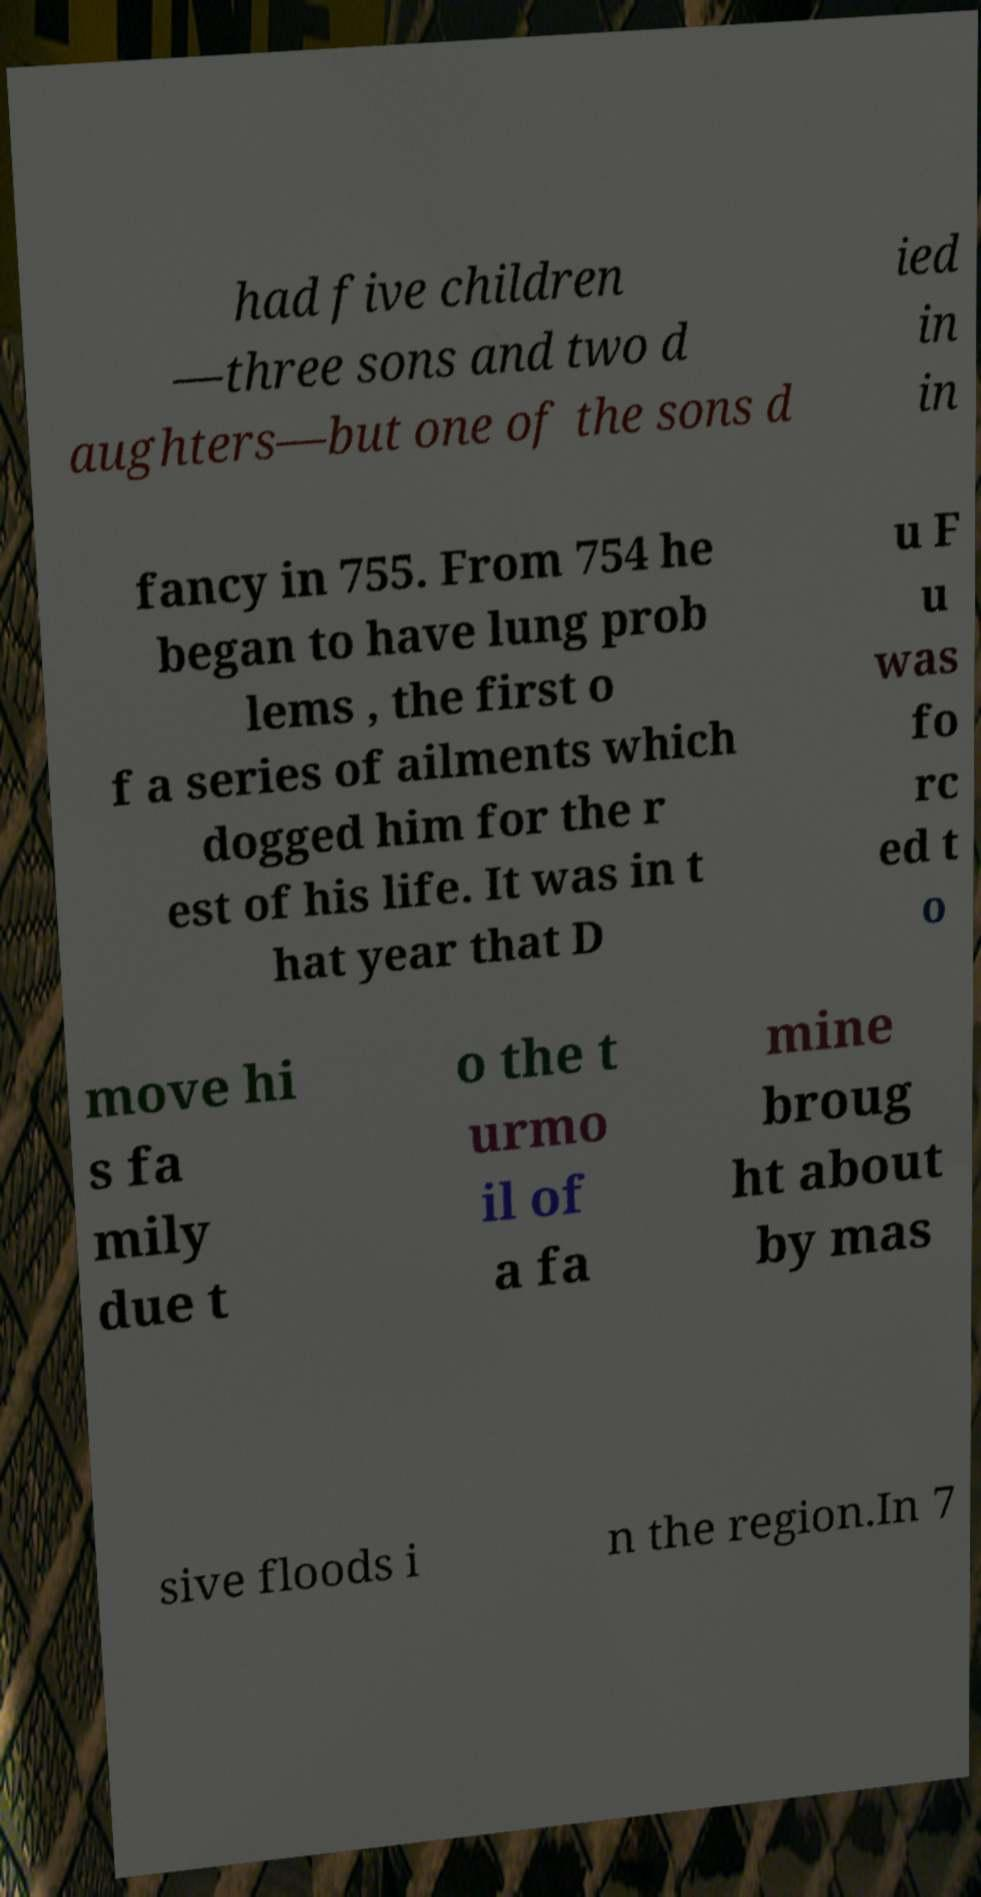There's text embedded in this image that I need extracted. Can you transcribe it verbatim? had five children —three sons and two d aughters—but one of the sons d ied in in fancy in 755. From 754 he began to have lung prob lems , the first o f a series of ailments which dogged him for the r est of his life. It was in t hat year that D u F u was fo rc ed t o move hi s fa mily due t o the t urmo il of a fa mine broug ht about by mas sive floods i n the region.In 7 